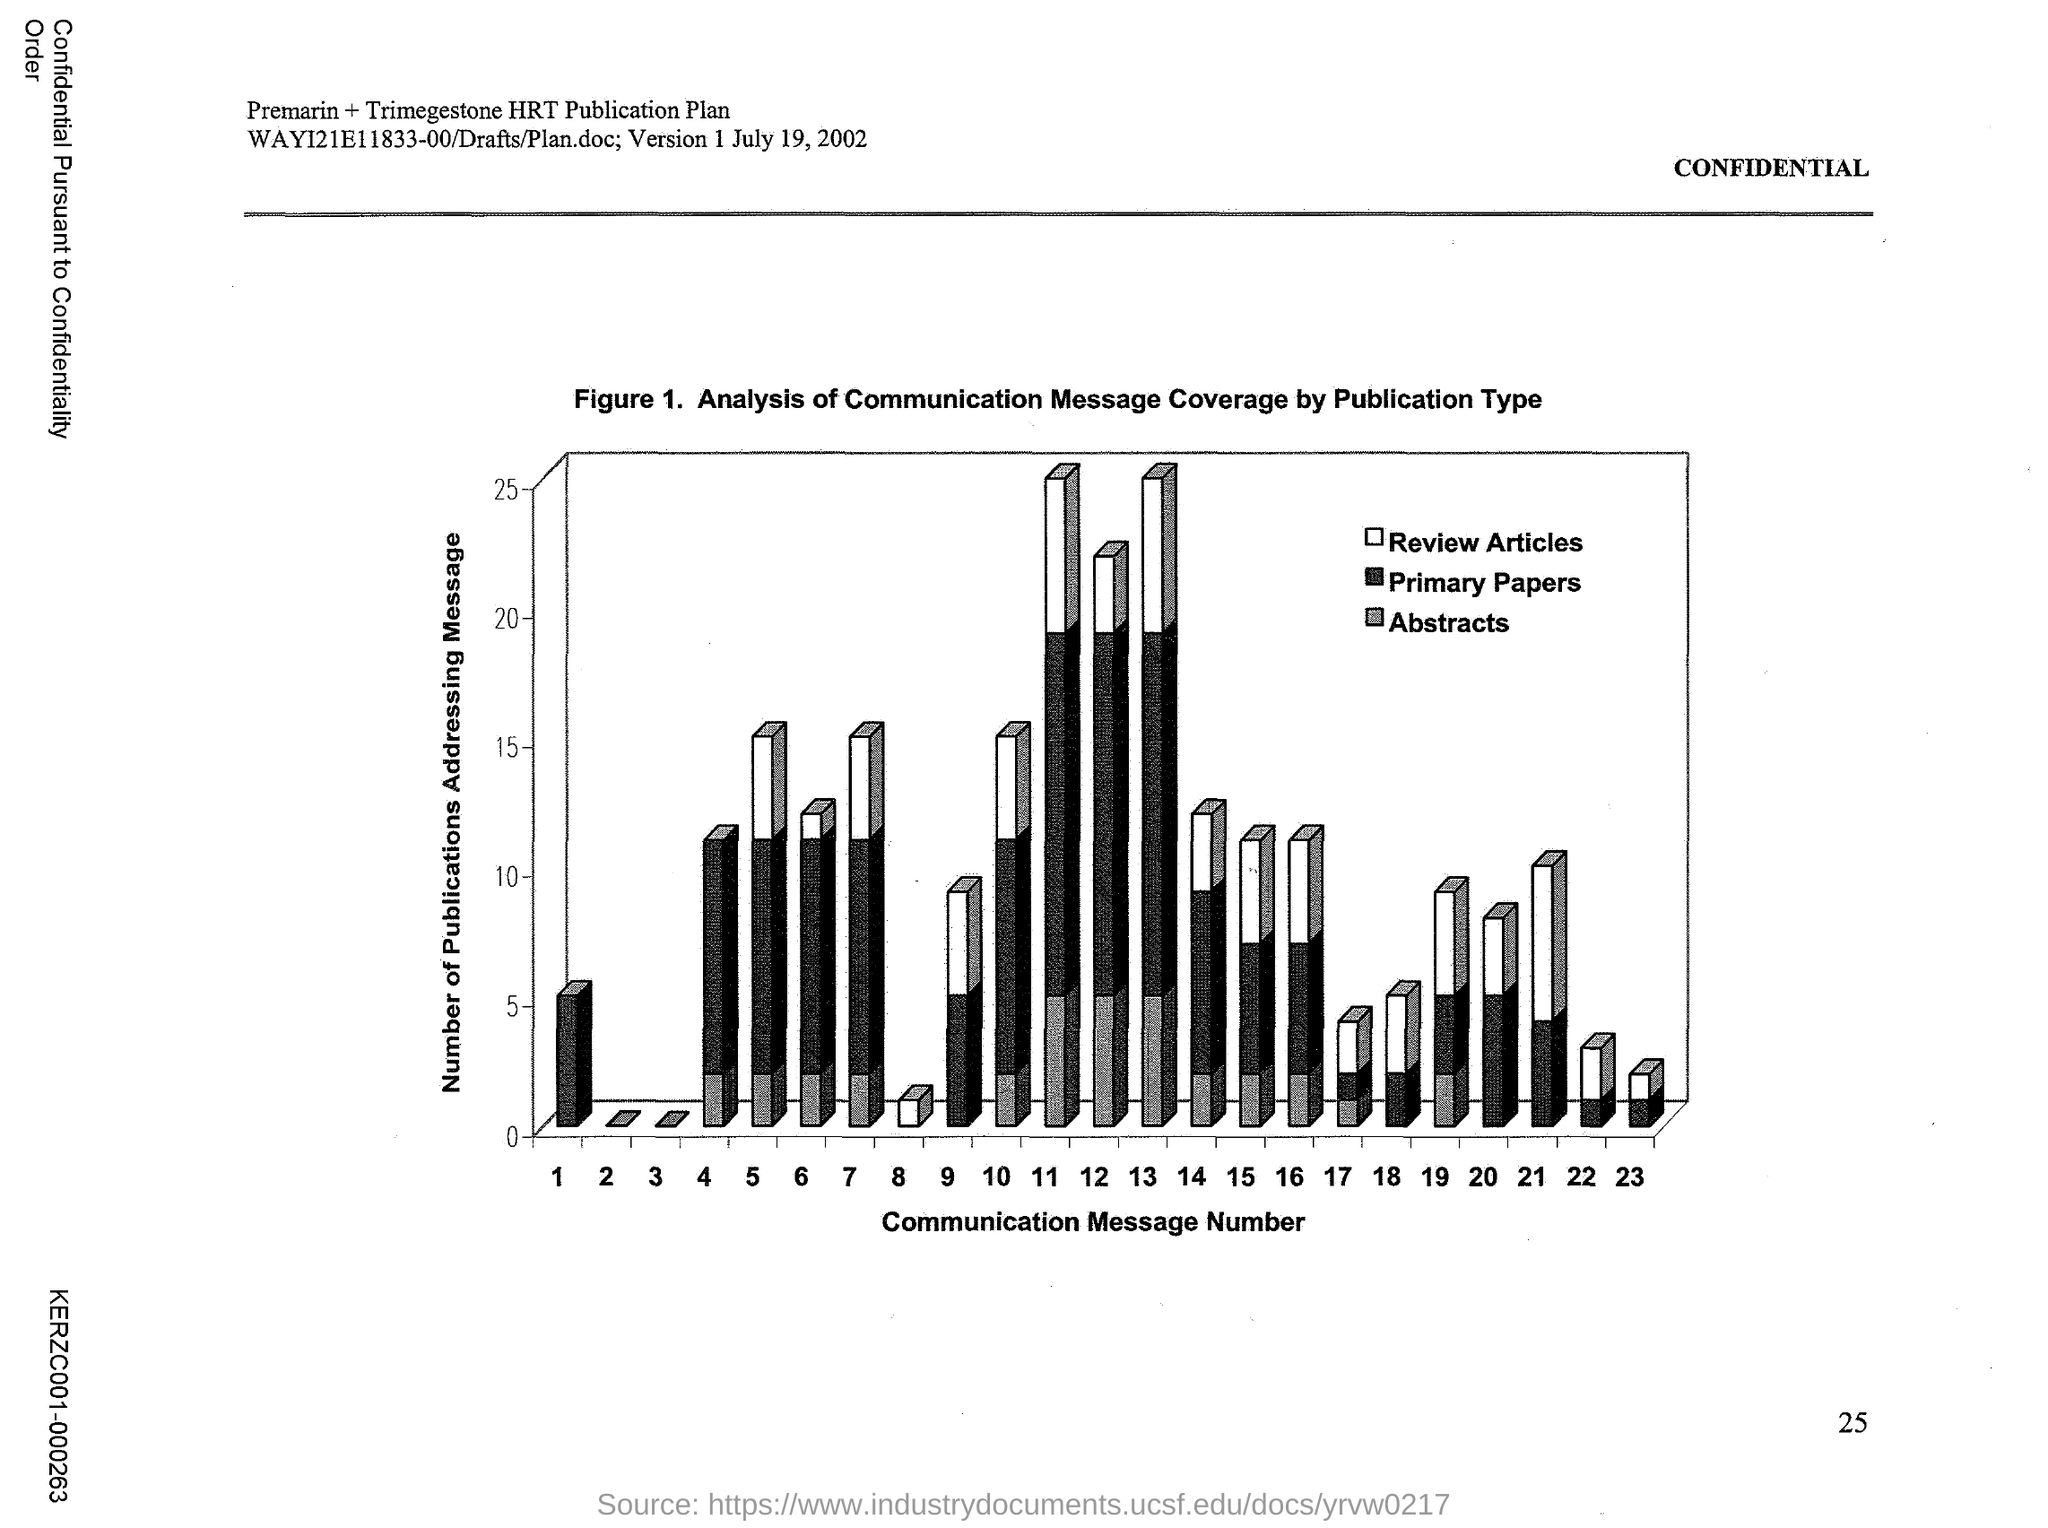What does the Figure 1. in this document represent?
Your answer should be very brief. Analysis of Communication Message Coverage by Publication Type. What does x-axis of Figure 1. represent?
Make the answer very short. Communication Message Number. What does y-axis of Figure 1. represent?
Your answer should be very brief. Number of Publications Addressing Message. 